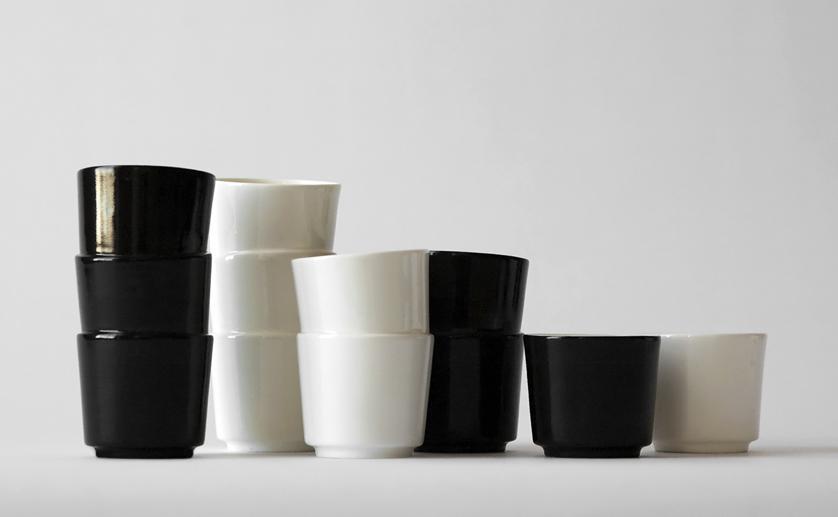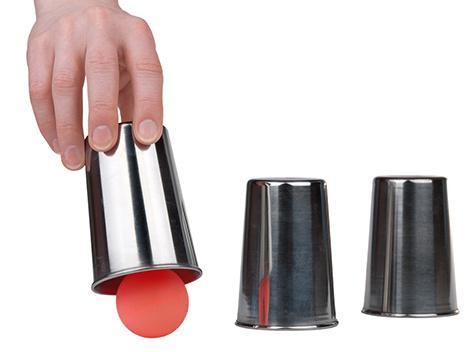The first image is the image on the left, the second image is the image on the right. Analyze the images presented: Is the assertion "There is no more than one red ball." valid? Answer yes or no. Yes. 